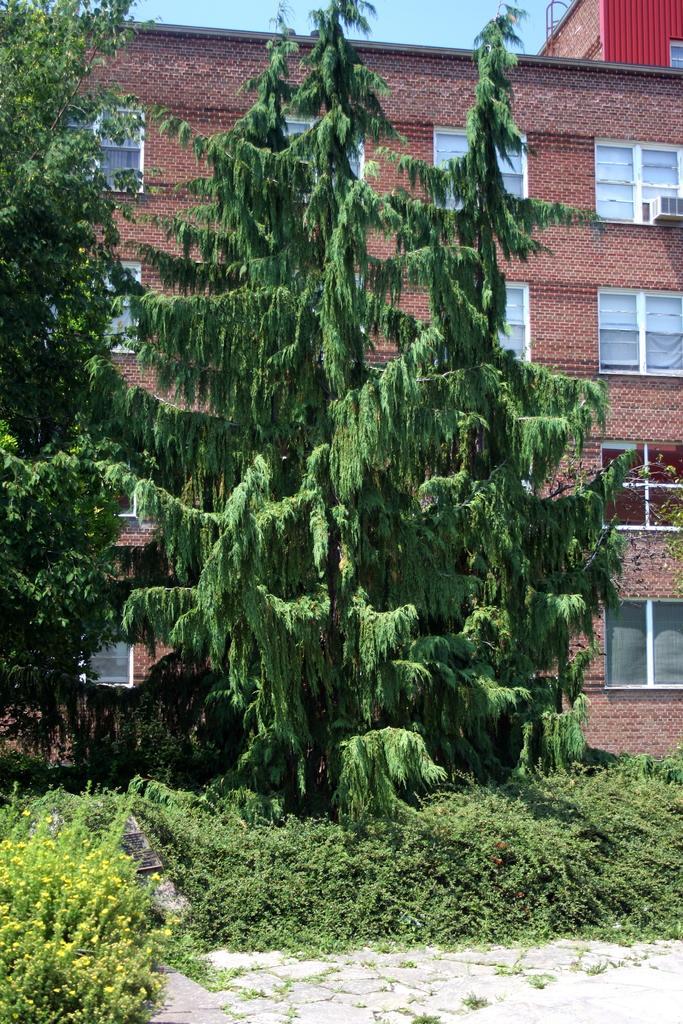How would you summarize this image in a sentence or two? We can see plants and trees. In the background we can see building,windows and sky. 